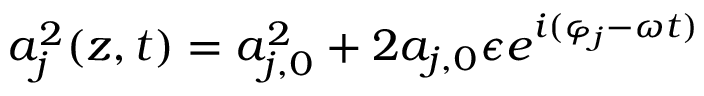Convert formula to latex. <formula><loc_0><loc_0><loc_500><loc_500>a _ { j } ^ { 2 } ( z , t ) = a _ { j , 0 } ^ { 2 } + 2 a _ { j , 0 } \epsilon e ^ { i ( \varphi _ { j } - \omega t ) }</formula> 